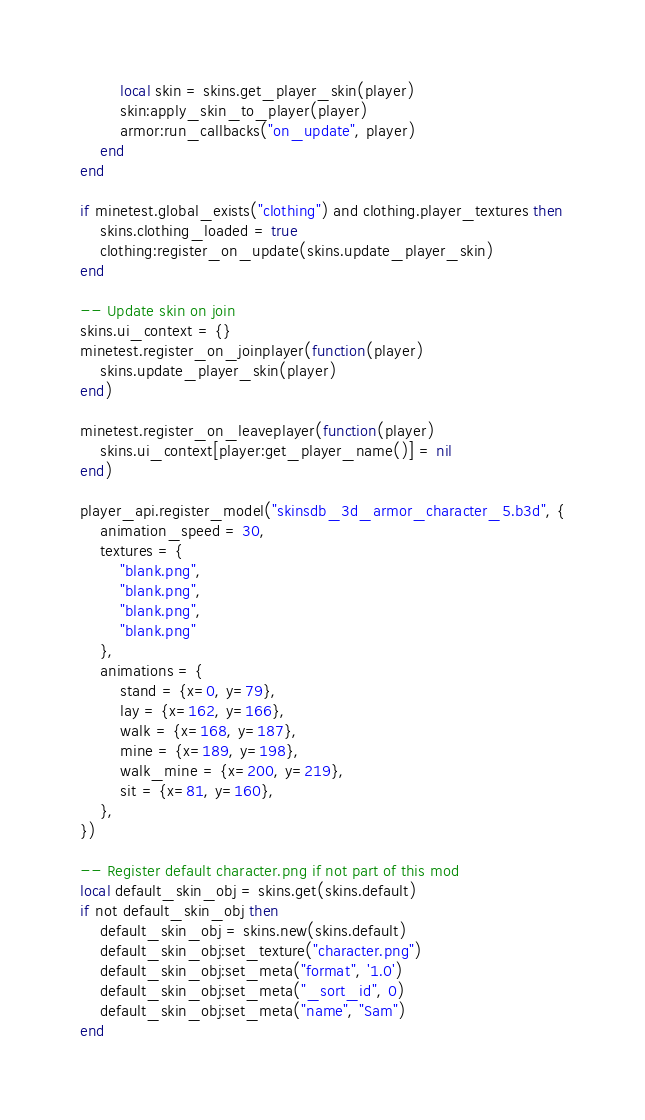Convert code to text. <code><loc_0><loc_0><loc_500><loc_500><_Lua_>		local skin = skins.get_player_skin(player)
		skin:apply_skin_to_player(player)
		armor:run_callbacks("on_update", player)
	end
end

if minetest.global_exists("clothing") and clothing.player_textures then
	skins.clothing_loaded = true
	clothing:register_on_update(skins.update_player_skin)
end

-- Update skin on join
skins.ui_context = {}
minetest.register_on_joinplayer(function(player)
	skins.update_player_skin(player)
end)

minetest.register_on_leaveplayer(function(player)
	skins.ui_context[player:get_player_name()] = nil
end)

player_api.register_model("skinsdb_3d_armor_character_5.b3d", {
	animation_speed = 30,
	textures = {
		"blank.png",
		"blank.png",
		"blank.png",
		"blank.png"
	},
	animations = {
		stand = {x=0, y=79},
		lay = {x=162, y=166},
		walk = {x=168, y=187},
		mine = {x=189, y=198},
		walk_mine = {x=200, y=219},
		sit = {x=81, y=160},
	},
})

-- Register default character.png if not part of this mod
local default_skin_obj = skins.get(skins.default)
if not default_skin_obj then
	default_skin_obj = skins.new(skins.default)
	default_skin_obj:set_texture("character.png")
	default_skin_obj:set_meta("format", '1.0')
	default_skin_obj:set_meta("_sort_id", 0)
	default_skin_obj:set_meta("name", "Sam")
end
</code> 